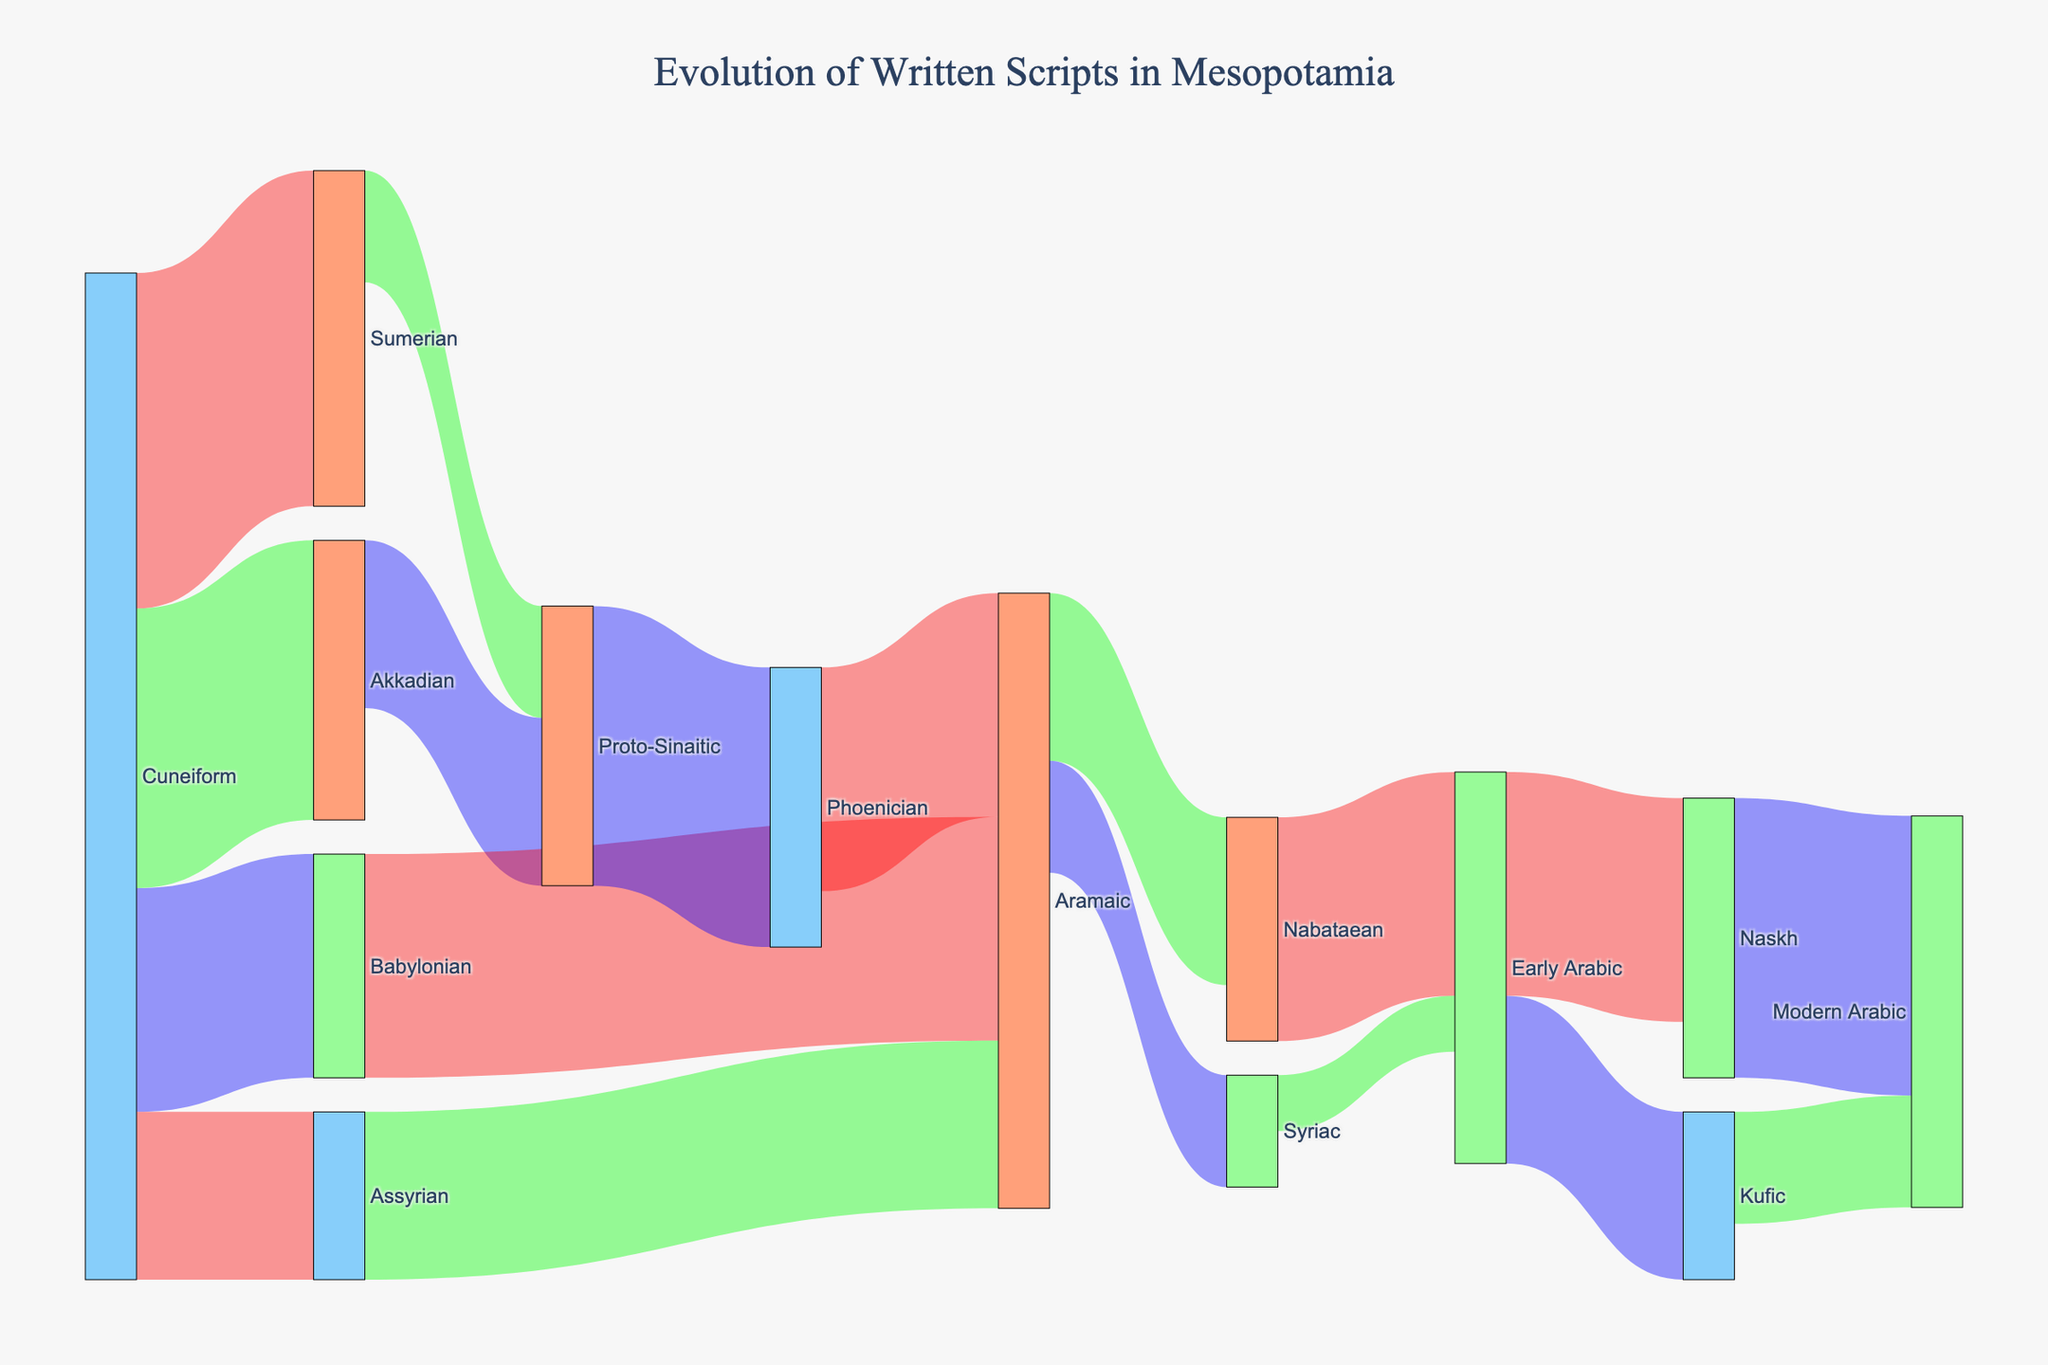What is the title of the Sankey Diagram? The title is usually displayed prominently at the top of the diagram. The title in this figure is "Evolution of Written Scripts in Mesopotamia".
Answer: Evolution of Written Scripts in Mesopotamia How many script transitions does Cuneiform make? By reviewing the Sankey diagram, we can see multiple flows from Cuneiform. These flows connect Cuneiform to Sumerian, Akkadian, Babylonian, and Assyrian making it a total of 4 transitions.
Answer: 4 What scripts contribute to the development of Proto-Sinaitic? Observe the Sankey diagram to identify the nodes pointing towards Proto-Sinaitic from Cuneiform, Sumerian, and Akkadian. Sumerian and Akkadian both flow into Proto-Sinaitic.
Answer: Sumerian, Akkadian Which script is a direct predecessor of Modern Arabic? Follow the flows leading to Modern Arabic, and observe that both Kufic and Naskh flow directly into Modern Arabic.
Answer: Kufic, Naskh Between Early Arabic and Aramaic, which has more script successors? Follow the flows from both Early Arabic and Aramaic nodes. Early Arabic has direct successors Kufic and Naskh (2), while Aramaic has Nabataean and Syriac (2) as successors.
Answer: Equal (2 each) Which transition from Cuneiform has the smallest value? By looking at the thickness of the connections emanating from Cuneiform, we see that the link to Assyrian with the smallest value of 15.
Answer: Assyrian How many scripts does Early Arabic directly lead to? Examine the flows from Early Arabic, which connect to Kufic and Naskh, making it 2 scripts.
Answer: 2 What is the total value flowing into Modern Arabic? From the Sankey diagram, trace all the flows leading to Modern Arabic and sum their values: Kufic (10) + Naskh (25) = 35.
Answer: 35 Which script has the highest number of direct predecessors? By counting the number of flows pointing to different scripts, it shows that both Aramaic and Early Arabic have the highest numbers of predecessors (3 each), from Babylonian, Assyrian, Phoenician (for Aramaic), and Nabataean, Syriac (for Early Arabic).
Answer: Aramaic, Early Arabic What is the combined value flowing out of Proto-Sinaitic? Check the flows originating from Proto-Sinaitic and sum the values: Phoenician (25).
Answer: 25 